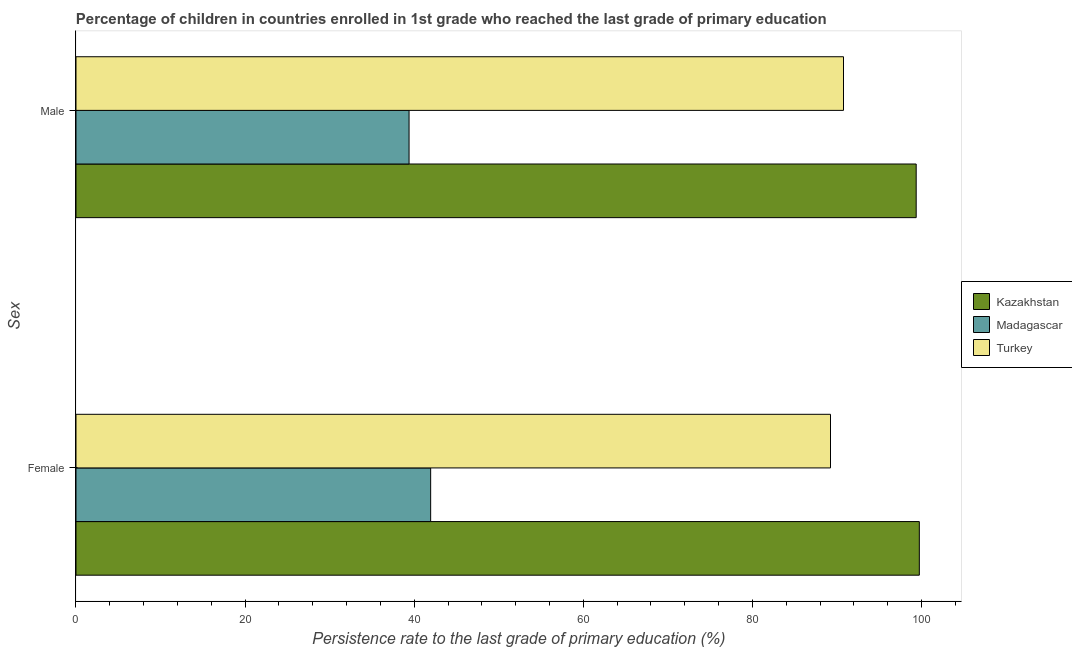How many different coloured bars are there?
Your answer should be compact. 3. How many bars are there on the 2nd tick from the bottom?
Keep it short and to the point. 3. What is the label of the 1st group of bars from the top?
Make the answer very short. Male. What is the persistence rate of female students in Kazakhstan?
Offer a very short reply. 99.74. Across all countries, what is the maximum persistence rate of female students?
Provide a short and direct response. 99.74. Across all countries, what is the minimum persistence rate of male students?
Offer a very short reply. 39.39. In which country was the persistence rate of female students maximum?
Give a very brief answer. Kazakhstan. In which country was the persistence rate of male students minimum?
Give a very brief answer. Madagascar. What is the total persistence rate of female students in the graph?
Offer a terse response. 230.93. What is the difference between the persistence rate of male students in Turkey and that in Madagascar?
Make the answer very short. 51.38. What is the difference between the persistence rate of female students in Turkey and the persistence rate of male students in Madagascar?
Give a very brief answer. 49.84. What is the average persistence rate of male students per country?
Your answer should be compact. 76.51. What is the difference between the persistence rate of male students and persistence rate of female students in Madagascar?
Offer a very short reply. -2.55. What is the ratio of the persistence rate of male students in Kazakhstan to that in Turkey?
Make the answer very short. 1.09. Is the persistence rate of male students in Madagascar less than that in Kazakhstan?
Offer a terse response. Yes. What does the 3rd bar from the bottom in Female represents?
Offer a very short reply. Turkey. How many countries are there in the graph?
Your response must be concise. 3. Does the graph contain grids?
Give a very brief answer. No. Where does the legend appear in the graph?
Provide a succinct answer. Center right. How are the legend labels stacked?
Provide a short and direct response. Vertical. What is the title of the graph?
Your response must be concise. Percentage of children in countries enrolled in 1st grade who reached the last grade of primary education. What is the label or title of the X-axis?
Offer a terse response. Persistence rate to the last grade of primary education (%). What is the label or title of the Y-axis?
Your answer should be compact. Sex. What is the Persistence rate to the last grade of primary education (%) of Kazakhstan in Female?
Your response must be concise. 99.74. What is the Persistence rate to the last grade of primary education (%) in Madagascar in Female?
Offer a terse response. 41.95. What is the Persistence rate to the last grade of primary education (%) of Turkey in Female?
Give a very brief answer. 89.24. What is the Persistence rate to the last grade of primary education (%) of Kazakhstan in Male?
Your answer should be compact. 99.37. What is the Persistence rate to the last grade of primary education (%) in Madagascar in Male?
Make the answer very short. 39.39. What is the Persistence rate to the last grade of primary education (%) in Turkey in Male?
Your answer should be very brief. 90.78. Across all Sex, what is the maximum Persistence rate to the last grade of primary education (%) of Kazakhstan?
Offer a terse response. 99.74. Across all Sex, what is the maximum Persistence rate to the last grade of primary education (%) of Madagascar?
Your answer should be compact. 41.95. Across all Sex, what is the maximum Persistence rate to the last grade of primary education (%) of Turkey?
Offer a very short reply. 90.78. Across all Sex, what is the minimum Persistence rate to the last grade of primary education (%) of Kazakhstan?
Your answer should be very brief. 99.37. Across all Sex, what is the minimum Persistence rate to the last grade of primary education (%) of Madagascar?
Offer a very short reply. 39.39. Across all Sex, what is the minimum Persistence rate to the last grade of primary education (%) of Turkey?
Give a very brief answer. 89.24. What is the total Persistence rate to the last grade of primary education (%) in Kazakhstan in the graph?
Keep it short and to the point. 199.11. What is the total Persistence rate to the last grade of primary education (%) of Madagascar in the graph?
Offer a very short reply. 81.34. What is the total Persistence rate to the last grade of primary education (%) in Turkey in the graph?
Make the answer very short. 180.01. What is the difference between the Persistence rate to the last grade of primary education (%) in Kazakhstan in Female and that in Male?
Your response must be concise. 0.37. What is the difference between the Persistence rate to the last grade of primary education (%) in Madagascar in Female and that in Male?
Make the answer very short. 2.55. What is the difference between the Persistence rate to the last grade of primary education (%) of Turkey in Female and that in Male?
Offer a very short reply. -1.54. What is the difference between the Persistence rate to the last grade of primary education (%) of Kazakhstan in Female and the Persistence rate to the last grade of primary education (%) of Madagascar in Male?
Keep it short and to the point. 60.35. What is the difference between the Persistence rate to the last grade of primary education (%) of Kazakhstan in Female and the Persistence rate to the last grade of primary education (%) of Turkey in Male?
Your response must be concise. 8.97. What is the difference between the Persistence rate to the last grade of primary education (%) of Madagascar in Female and the Persistence rate to the last grade of primary education (%) of Turkey in Male?
Give a very brief answer. -48.83. What is the average Persistence rate to the last grade of primary education (%) in Kazakhstan per Sex?
Give a very brief answer. 99.56. What is the average Persistence rate to the last grade of primary education (%) in Madagascar per Sex?
Ensure brevity in your answer.  40.67. What is the average Persistence rate to the last grade of primary education (%) of Turkey per Sex?
Keep it short and to the point. 90.01. What is the difference between the Persistence rate to the last grade of primary education (%) in Kazakhstan and Persistence rate to the last grade of primary education (%) in Madagascar in Female?
Keep it short and to the point. 57.79. What is the difference between the Persistence rate to the last grade of primary education (%) in Kazakhstan and Persistence rate to the last grade of primary education (%) in Turkey in Female?
Provide a succinct answer. 10.51. What is the difference between the Persistence rate to the last grade of primary education (%) of Madagascar and Persistence rate to the last grade of primary education (%) of Turkey in Female?
Provide a short and direct response. -47.29. What is the difference between the Persistence rate to the last grade of primary education (%) in Kazakhstan and Persistence rate to the last grade of primary education (%) in Madagascar in Male?
Provide a short and direct response. 59.98. What is the difference between the Persistence rate to the last grade of primary education (%) of Kazakhstan and Persistence rate to the last grade of primary education (%) of Turkey in Male?
Keep it short and to the point. 8.6. What is the difference between the Persistence rate to the last grade of primary education (%) of Madagascar and Persistence rate to the last grade of primary education (%) of Turkey in Male?
Make the answer very short. -51.38. What is the ratio of the Persistence rate to the last grade of primary education (%) in Madagascar in Female to that in Male?
Provide a short and direct response. 1.06. What is the ratio of the Persistence rate to the last grade of primary education (%) in Turkey in Female to that in Male?
Make the answer very short. 0.98. What is the difference between the highest and the second highest Persistence rate to the last grade of primary education (%) of Kazakhstan?
Offer a very short reply. 0.37. What is the difference between the highest and the second highest Persistence rate to the last grade of primary education (%) of Madagascar?
Your answer should be compact. 2.55. What is the difference between the highest and the second highest Persistence rate to the last grade of primary education (%) of Turkey?
Ensure brevity in your answer.  1.54. What is the difference between the highest and the lowest Persistence rate to the last grade of primary education (%) in Kazakhstan?
Ensure brevity in your answer.  0.37. What is the difference between the highest and the lowest Persistence rate to the last grade of primary education (%) in Madagascar?
Offer a very short reply. 2.55. What is the difference between the highest and the lowest Persistence rate to the last grade of primary education (%) in Turkey?
Make the answer very short. 1.54. 